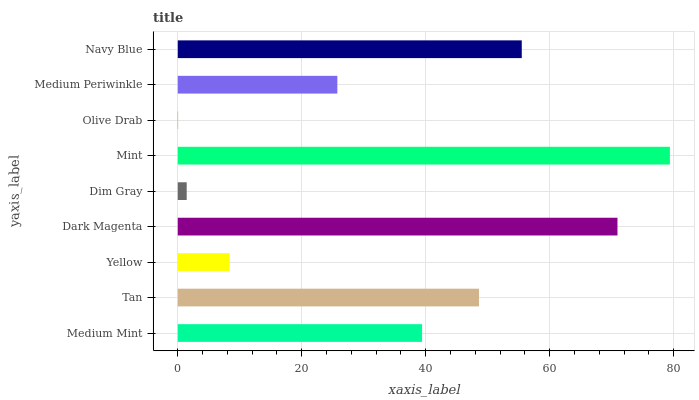Is Olive Drab the minimum?
Answer yes or no. Yes. Is Mint the maximum?
Answer yes or no. Yes. Is Tan the minimum?
Answer yes or no. No. Is Tan the maximum?
Answer yes or no. No. Is Tan greater than Medium Mint?
Answer yes or no. Yes. Is Medium Mint less than Tan?
Answer yes or no. Yes. Is Medium Mint greater than Tan?
Answer yes or no. No. Is Tan less than Medium Mint?
Answer yes or no. No. Is Medium Mint the high median?
Answer yes or no. Yes. Is Medium Mint the low median?
Answer yes or no. Yes. Is Dark Magenta the high median?
Answer yes or no. No. Is Yellow the low median?
Answer yes or no. No. 